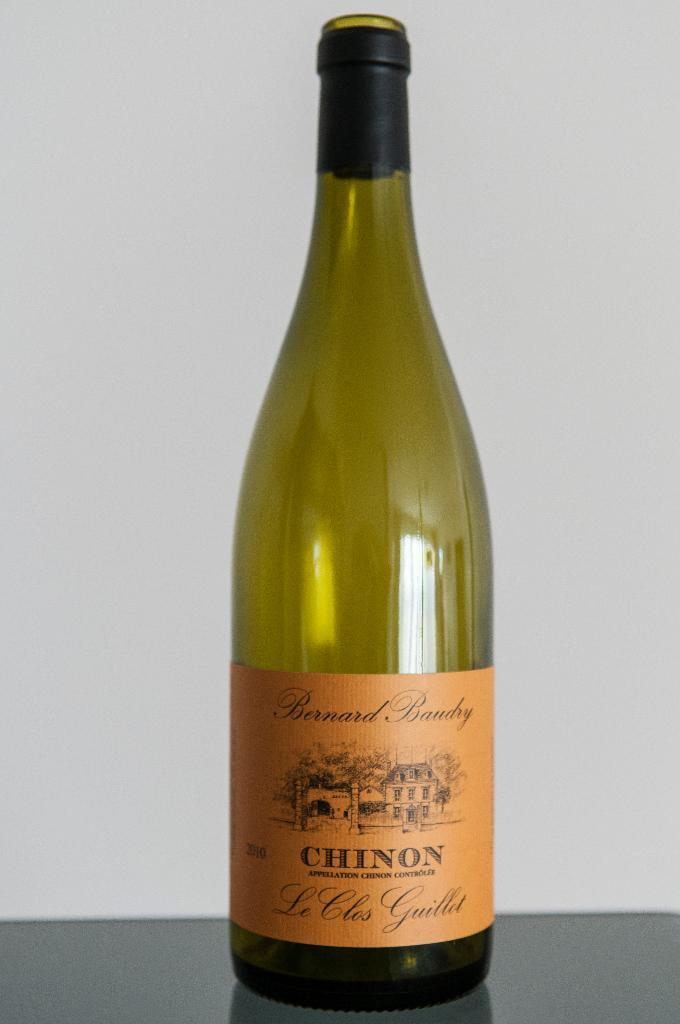<image>
Write a terse but informative summary of the picture. An empty bottle of Chinon is on a black table. 